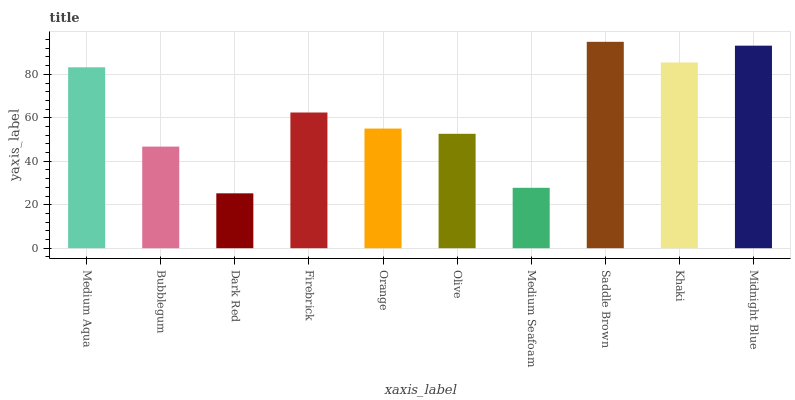Is Dark Red the minimum?
Answer yes or no. Yes. Is Saddle Brown the maximum?
Answer yes or no. Yes. Is Bubblegum the minimum?
Answer yes or no. No. Is Bubblegum the maximum?
Answer yes or no. No. Is Medium Aqua greater than Bubblegum?
Answer yes or no. Yes. Is Bubblegum less than Medium Aqua?
Answer yes or no. Yes. Is Bubblegum greater than Medium Aqua?
Answer yes or no. No. Is Medium Aqua less than Bubblegum?
Answer yes or no. No. Is Firebrick the high median?
Answer yes or no. Yes. Is Orange the low median?
Answer yes or no. Yes. Is Saddle Brown the high median?
Answer yes or no. No. Is Medium Aqua the low median?
Answer yes or no. No. 